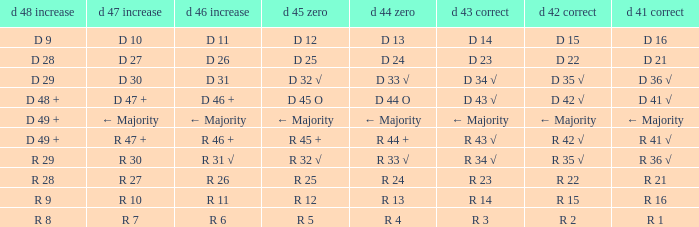What is the value of D 43 √ when the value of D 42 √ is d 42 √? D 43 √. 